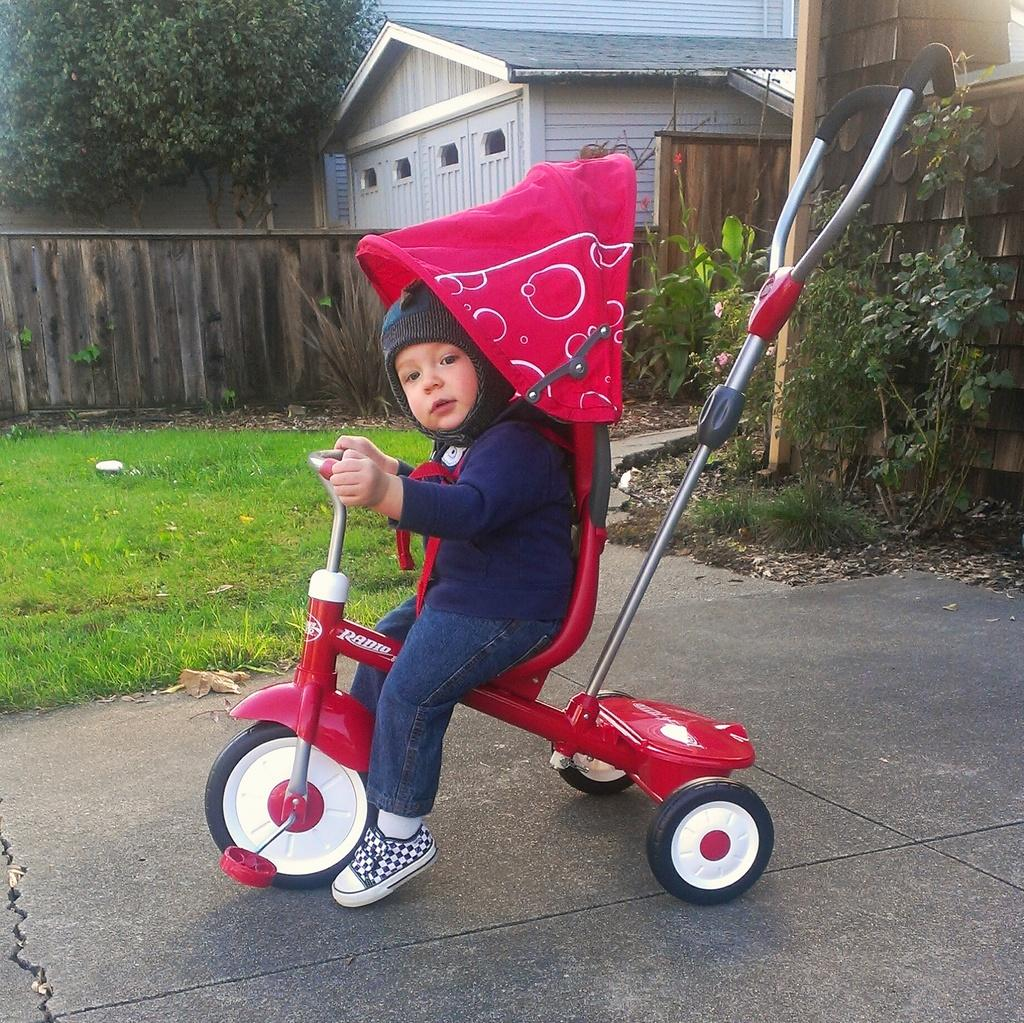What is the main subject of the image? The main subject of the image is a boy. What is the boy wearing? The boy is wearing a t-shirt, trousers, shoes, and a cap. What activity is the boy engaged in? The boy is riding a bicycle. What can be seen in the background of the image? There are plants, grass, houses, trees, and a wall in the background of the image. What is the boy's temper like in the image? The image does not provide information about the boy's temper. How does the boy express disgust in the image? There is no indication of the boy expressing disgust in the image. 